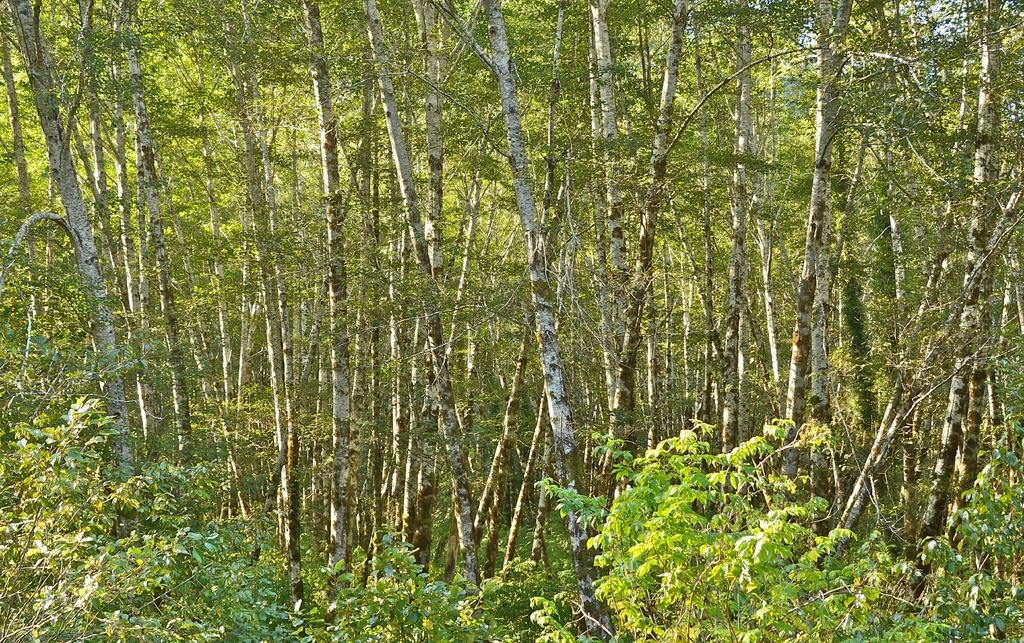What type of vegetation can be seen in the image? There are trees in the image. What is the color of the trees in the image? The trees are green in color. What is visible in the background of the image? The sky is visible in the background of the image. What is the color of the sky in the image? The sky is white in color. What type of sweater is hanging on the tree in the image? There is no sweater present in the image; it only features trees and a white sky. How many times does the tongue roll around in the image? There is no tongue present in the image, so it cannot roll around. 